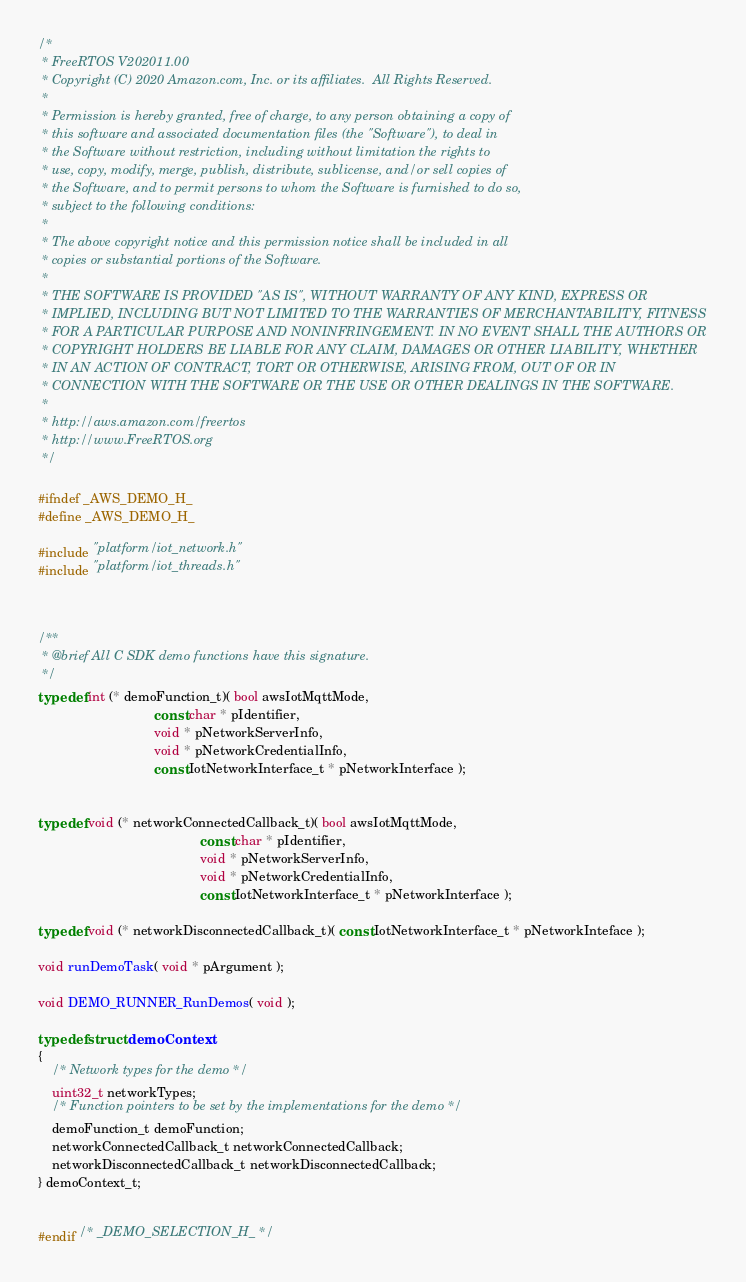<code> <loc_0><loc_0><loc_500><loc_500><_C_>/*
 * FreeRTOS V202011.00
 * Copyright (C) 2020 Amazon.com, Inc. or its affiliates.  All Rights Reserved.
 *
 * Permission is hereby granted, free of charge, to any person obtaining a copy of
 * this software and associated documentation files (the "Software"), to deal in
 * the Software without restriction, including without limitation the rights to
 * use, copy, modify, merge, publish, distribute, sublicense, and/or sell copies of
 * the Software, and to permit persons to whom the Software is furnished to do so,
 * subject to the following conditions:
 *
 * The above copyright notice and this permission notice shall be included in all
 * copies or substantial portions of the Software.
 *
 * THE SOFTWARE IS PROVIDED "AS IS", WITHOUT WARRANTY OF ANY KIND, EXPRESS OR
 * IMPLIED, INCLUDING BUT NOT LIMITED TO THE WARRANTIES OF MERCHANTABILITY, FITNESS
 * FOR A PARTICULAR PURPOSE AND NONINFRINGEMENT. IN NO EVENT SHALL THE AUTHORS OR
 * COPYRIGHT HOLDERS BE LIABLE FOR ANY CLAIM, DAMAGES OR OTHER LIABILITY, WHETHER
 * IN AN ACTION OF CONTRACT, TORT OR OTHERWISE, ARISING FROM, OUT OF OR IN
 * CONNECTION WITH THE SOFTWARE OR THE USE OR OTHER DEALINGS IN THE SOFTWARE.
 *
 * http://aws.amazon.com/freertos
 * http://www.FreeRTOS.org
 */

#ifndef _AWS_DEMO_H_
#define _AWS_DEMO_H_

#include "platform/iot_network.h"
#include "platform/iot_threads.h"



/**
 * @brief All C SDK demo functions have this signature.
 */
typedef int (* demoFunction_t)( bool awsIotMqttMode,
                                const char * pIdentifier,
                                void * pNetworkServerInfo,
                                void * pNetworkCredentialInfo,
                                const IotNetworkInterface_t * pNetworkInterface );


typedef void (* networkConnectedCallback_t)( bool awsIotMqttMode,
                                             const char * pIdentifier,
                                             void * pNetworkServerInfo,
                                             void * pNetworkCredentialInfo,
                                             const IotNetworkInterface_t * pNetworkInterface );

typedef void (* networkDisconnectedCallback_t)( const IotNetworkInterface_t * pNetworkInteface );

void runDemoTask( void * pArgument );

void DEMO_RUNNER_RunDemos( void );

typedef struct demoContext
{
    /* Network types for the demo */
    uint32_t networkTypes;
    /* Function pointers to be set by the implementations for the demo */
    demoFunction_t demoFunction;
    networkConnectedCallback_t networkConnectedCallback;
    networkDisconnectedCallback_t networkDisconnectedCallback;
} demoContext_t;


#endif /* _DEMO_SELECTION_H_ */
</code> 